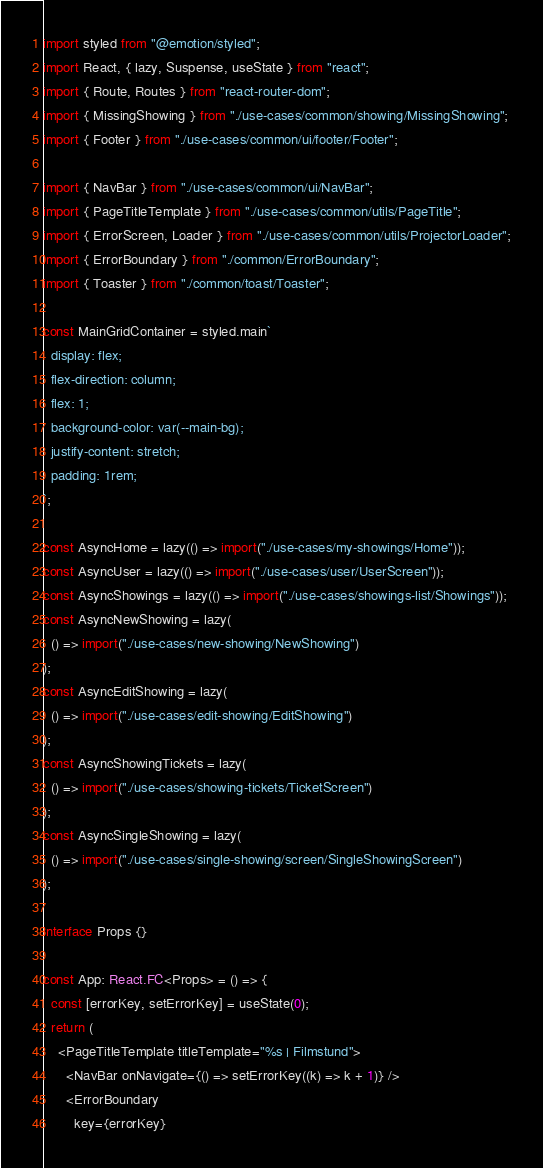Convert code to text. <code><loc_0><loc_0><loc_500><loc_500><_TypeScript_>import styled from "@emotion/styled";
import React, { lazy, Suspense, useState } from "react";
import { Route, Routes } from "react-router-dom";
import { MissingShowing } from "./use-cases/common/showing/MissingShowing";
import { Footer } from "./use-cases/common/ui/footer/Footer";

import { NavBar } from "./use-cases/common/ui/NavBar";
import { PageTitleTemplate } from "./use-cases/common/utils/PageTitle";
import { ErrorScreen, Loader } from "./use-cases/common/utils/ProjectorLoader";
import { ErrorBoundary } from "./common/ErrorBoundary";
import { Toaster } from "./common/toast/Toaster";

const MainGridContainer = styled.main`
  display: flex;
  flex-direction: column;
  flex: 1;
  background-color: var(--main-bg);
  justify-content: stretch;
  padding: 1rem;
`;

const AsyncHome = lazy(() => import("./use-cases/my-showings/Home"));
const AsyncUser = lazy(() => import("./use-cases/user/UserScreen"));
const AsyncShowings = lazy(() => import("./use-cases/showings-list/Showings"));
const AsyncNewShowing = lazy(
  () => import("./use-cases/new-showing/NewShowing")
);
const AsyncEditShowing = lazy(
  () => import("./use-cases/edit-showing/EditShowing")
);
const AsyncShowingTickets = lazy(
  () => import("./use-cases/showing-tickets/TicketScreen")
);
const AsyncSingleShowing = lazy(
  () => import("./use-cases/single-showing/screen/SingleShowingScreen")
);

interface Props {}

const App: React.FC<Props> = () => {
  const [errorKey, setErrorKey] = useState(0);
  return (
    <PageTitleTemplate titleTemplate="%s | Filmstund">
      <NavBar onNavigate={() => setErrorKey((k) => k + 1)} />
      <ErrorBoundary
        key={errorKey}</code> 